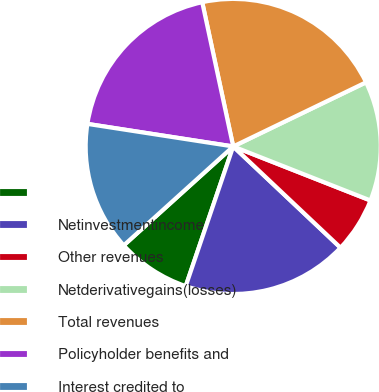<chart> <loc_0><loc_0><loc_500><loc_500><pie_chart><ecel><fcel>Netinvestmentincome<fcel>Other revenues<fcel>Netderivativegains(losses)<fcel>Total revenues<fcel>Policyholder benefits and<fcel>Interest credited to<nl><fcel>8.09%<fcel>18.18%<fcel>6.07%<fcel>13.13%<fcel>21.21%<fcel>19.19%<fcel>14.14%<nl></chart> 